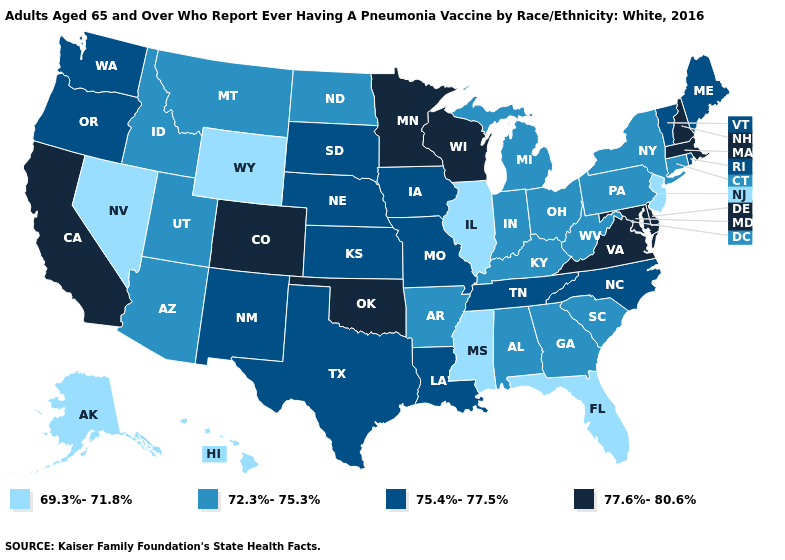What is the lowest value in the USA?
Give a very brief answer. 69.3%-71.8%. Name the states that have a value in the range 77.6%-80.6%?
Quick response, please. California, Colorado, Delaware, Maryland, Massachusetts, Minnesota, New Hampshire, Oklahoma, Virginia, Wisconsin. Among the states that border Oregon , which have the lowest value?
Be succinct. Nevada. Among the states that border Pennsylvania , does Ohio have the highest value?
Keep it brief. No. How many symbols are there in the legend?
Quick response, please. 4. Name the states that have a value in the range 69.3%-71.8%?
Write a very short answer. Alaska, Florida, Hawaii, Illinois, Mississippi, Nevada, New Jersey, Wyoming. Name the states that have a value in the range 72.3%-75.3%?
Write a very short answer. Alabama, Arizona, Arkansas, Connecticut, Georgia, Idaho, Indiana, Kentucky, Michigan, Montana, New York, North Dakota, Ohio, Pennsylvania, South Carolina, Utah, West Virginia. Does the first symbol in the legend represent the smallest category?
Answer briefly. Yes. Name the states that have a value in the range 69.3%-71.8%?
Concise answer only. Alaska, Florida, Hawaii, Illinois, Mississippi, Nevada, New Jersey, Wyoming. What is the value of West Virginia?
Short answer required. 72.3%-75.3%. How many symbols are there in the legend?
Quick response, please. 4. Name the states that have a value in the range 77.6%-80.6%?
Write a very short answer. California, Colorado, Delaware, Maryland, Massachusetts, Minnesota, New Hampshire, Oklahoma, Virginia, Wisconsin. Name the states that have a value in the range 77.6%-80.6%?
Give a very brief answer. California, Colorado, Delaware, Maryland, Massachusetts, Minnesota, New Hampshire, Oklahoma, Virginia, Wisconsin. Name the states that have a value in the range 75.4%-77.5%?
Give a very brief answer. Iowa, Kansas, Louisiana, Maine, Missouri, Nebraska, New Mexico, North Carolina, Oregon, Rhode Island, South Dakota, Tennessee, Texas, Vermont, Washington. Name the states that have a value in the range 72.3%-75.3%?
Keep it brief. Alabama, Arizona, Arkansas, Connecticut, Georgia, Idaho, Indiana, Kentucky, Michigan, Montana, New York, North Dakota, Ohio, Pennsylvania, South Carolina, Utah, West Virginia. 